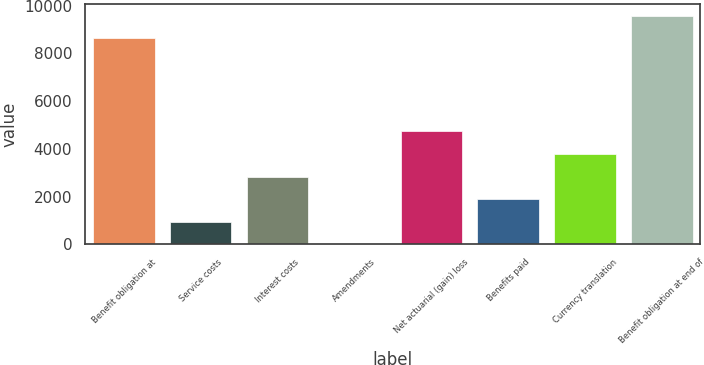<chart> <loc_0><loc_0><loc_500><loc_500><bar_chart><fcel>Benefit obligation at<fcel>Service costs<fcel>Interest costs<fcel>Amendments<fcel>Net actuarial (gain) loss<fcel>Benefits paid<fcel>Currency translation<fcel>Benefit obligation at end of<nl><fcel>8635<fcel>948.1<fcel>2840.3<fcel>2<fcel>4732.5<fcel>1894.2<fcel>3786.4<fcel>9581.1<nl></chart> 